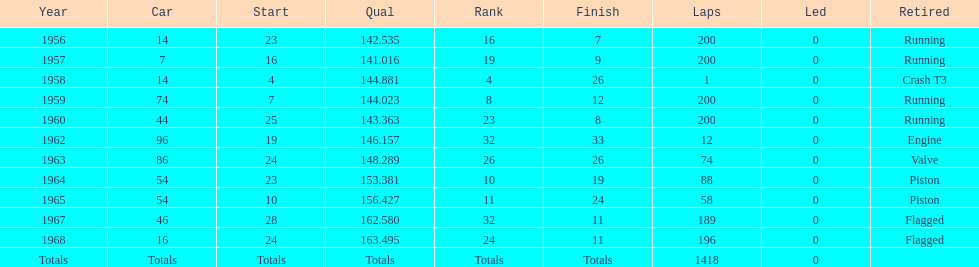Could you help me parse every detail presented in this table? {'header': ['Year', 'Car', 'Start', 'Qual', 'Rank', 'Finish', 'Laps', 'Led', 'Retired'], 'rows': [['1956', '14', '23', '142.535', '16', '7', '200', '0', 'Running'], ['1957', '7', '16', '141.016', '19', '9', '200', '0', 'Running'], ['1958', '14', '4', '144.881', '4', '26', '1', '0', 'Crash T3'], ['1959', '74', '7', '144.023', '8', '12', '200', '0', 'Running'], ['1960', '44', '25', '143.363', '23', '8', '200', '0', 'Running'], ['1962', '96', '19', '146.157', '32', '33', '12', '0', 'Engine'], ['1963', '86', '24', '148.289', '26', '26', '74', '0', 'Valve'], ['1964', '54', '23', '153.381', '10', '19', '88', '0', 'Piston'], ['1965', '54', '10', '156.427', '11', '24', '58', '0', 'Piston'], ['1967', '46', '28', '162.580', '32', '11', '189', '0', 'Flagged'], ['1968', '16', '24', '163.495', '24', '11', '196', '0', 'Flagged'], ['Totals', 'Totals', 'Totals', 'Totals', 'Totals', 'Totals', '1418', '0', '']]} In which year does the final qual appear on the chart? 1968. 